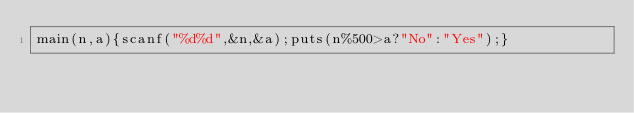Convert code to text. <code><loc_0><loc_0><loc_500><loc_500><_C_>main(n,a){scanf("%d%d",&n,&a);puts(n%500>a?"No":"Yes");}</code> 